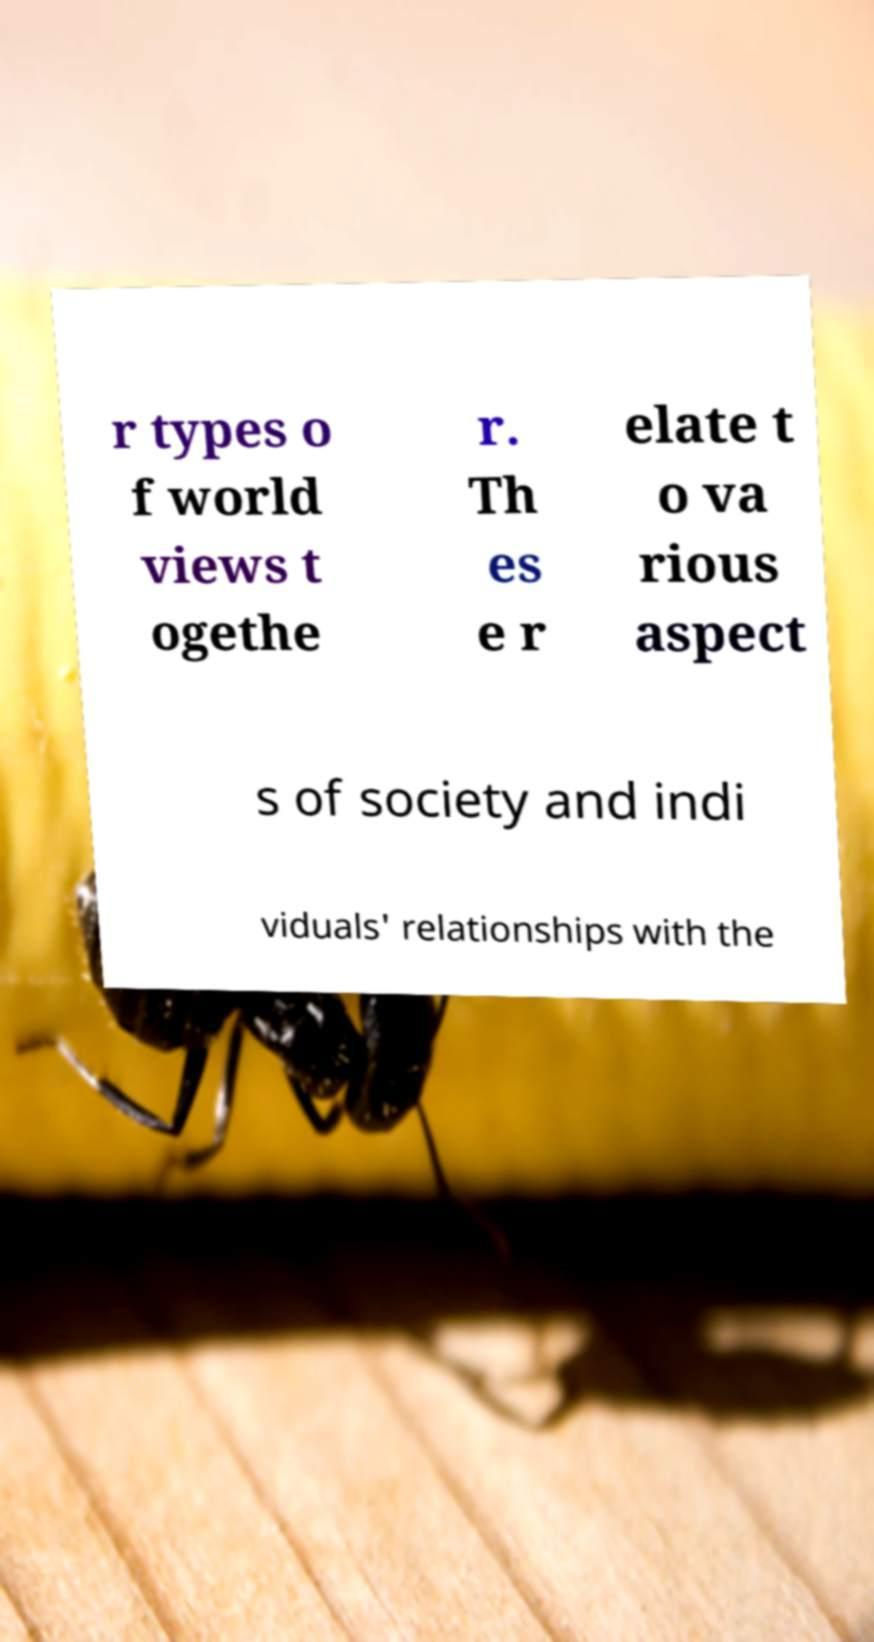Can you read and provide the text displayed in the image?This photo seems to have some interesting text. Can you extract and type it out for me? r types o f world views t ogethe r. Th es e r elate t o va rious aspect s of society and indi viduals' relationships with the 